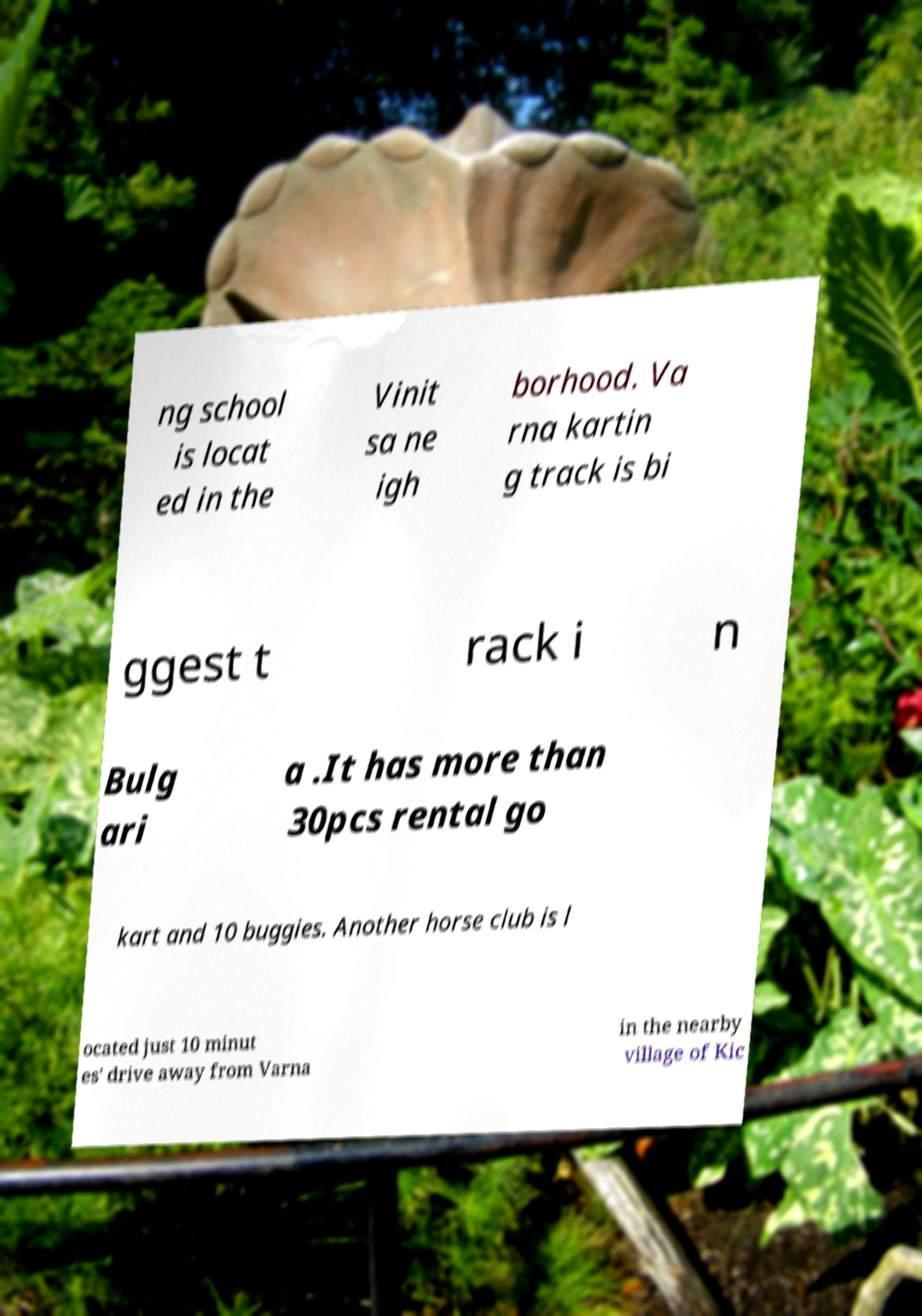For documentation purposes, I need the text within this image transcribed. Could you provide that? ng school is locat ed in the Vinit sa ne igh borhood. Va rna kartin g track is bi ggest t rack i n Bulg ari a .It has more than 30pcs rental go kart and 10 buggies. Another horse club is l ocated just 10 minut es' drive away from Varna in the nearby village of Kic 